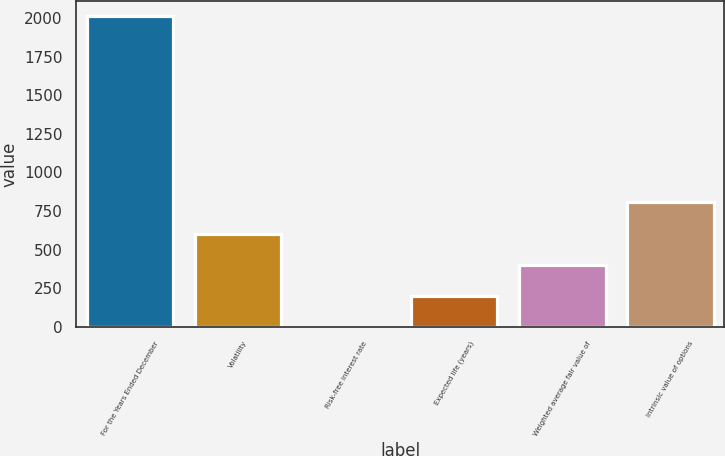Convert chart. <chart><loc_0><loc_0><loc_500><loc_500><bar_chart><fcel>For the Years Ended December<fcel>Volatility<fcel>Risk-free interest rate<fcel>Expected life (years)<fcel>Weighted average fair value of<fcel>Intrinsic value of options<nl><fcel>2011<fcel>604.84<fcel>2.2<fcel>203.08<fcel>403.96<fcel>805.72<nl></chart> 